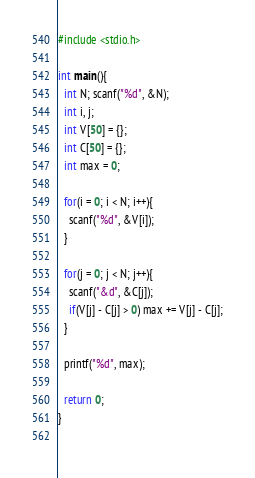<code> <loc_0><loc_0><loc_500><loc_500><_C_>#include <stdio.h>

int main(){
  int N; scanf("%d", &N);
  int i, j;
  int V[50] = {};
  int C[50] = {};
  int max = 0;
  
  for(i = 0; i < N; i++){
    scanf("%d", &V[i]);
  }

  for(j = 0; j < N; j++){
    scanf("&d", &C[j]);
    if(V[j] - C[j] > 0) max += V[j] - C[j];
  }

  printf("%d", max);

  return 0;
}
  
</code> 